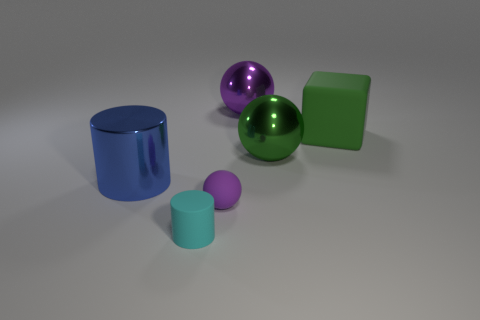Add 1 small rubber things. How many objects exist? 7 Subtract all blocks. How many objects are left? 5 Add 2 large cylinders. How many large cylinders exist? 3 Subtract 0 red spheres. How many objects are left? 6 Subtract all tiny cyan matte things. Subtract all purple matte spheres. How many objects are left? 4 Add 5 purple rubber things. How many purple rubber things are left? 6 